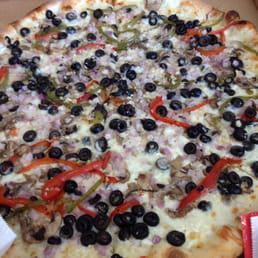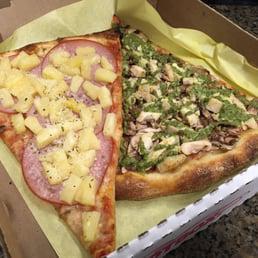The first image is the image on the left, the second image is the image on the right. For the images shown, is this caption "There are two whole pizzas ready to eat." true? Answer yes or no. No. The first image is the image on the left, the second image is the image on the right. Considering the images on both sides, is "One image shows a whole pizza with black olives and red pepper strips on top, and the other image shows no more than two wedge-shaped slices on something made of paper." valid? Answer yes or no. Yes. 